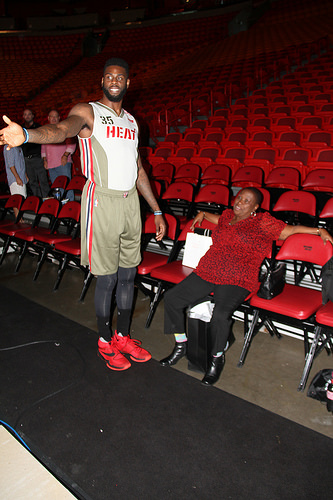<image>
Is the chair on the lady? No. The chair is not positioned on the lady. They may be near each other, but the chair is not supported by or resting on top of the lady. Where is the shoes in relation to the chair? Is it in front of the chair? Yes. The shoes is positioned in front of the chair, appearing closer to the camera viewpoint. Is there a man above the floor? No. The man is not positioned above the floor. The vertical arrangement shows a different relationship. 